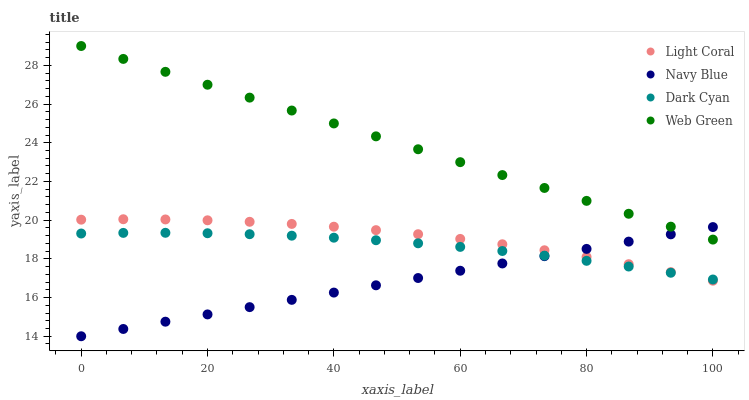Does Navy Blue have the minimum area under the curve?
Answer yes or no. Yes. Does Web Green have the maximum area under the curve?
Answer yes or no. Yes. Does Dark Cyan have the minimum area under the curve?
Answer yes or no. No. Does Dark Cyan have the maximum area under the curve?
Answer yes or no. No. Is Navy Blue the smoothest?
Answer yes or no. Yes. Is Light Coral the roughest?
Answer yes or no. Yes. Is Dark Cyan the smoothest?
Answer yes or no. No. Is Dark Cyan the roughest?
Answer yes or no. No. Does Navy Blue have the lowest value?
Answer yes or no. Yes. Does Dark Cyan have the lowest value?
Answer yes or no. No. Does Web Green have the highest value?
Answer yes or no. Yes. Does Navy Blue have the highest value?
Answer yes or no. No. Is Dark Cyan less than Web Green?
Answer yes or no. Yes. Is Web Green greater than Dark Cyan?
Answer yes or no. Yes. Does Navy Blue intersect Light Coral?
Answer yes or no. Yes. Is Navy Blue less than Light Coral?
Answer yes or no. No. Is Navy Blue greater than Light Coral?
Answer yes or no. No. Does Dark Cyan intersect Web Green?
Answer yes or no. No. 